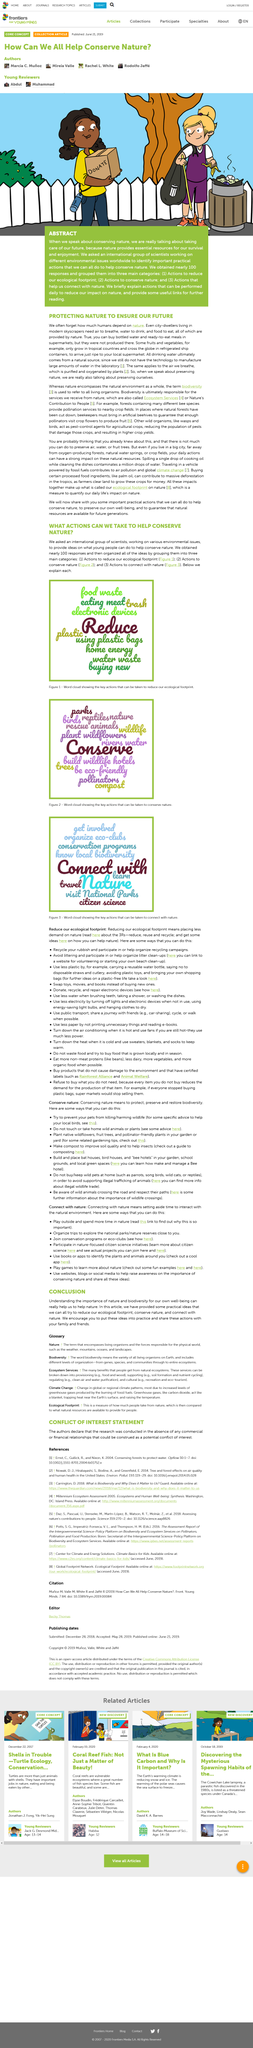Specify some key components in this picture. In nature, we find the essential resources necessary for our survival and enjoyment, which nature graciously provides for us. The article provided various ideas for reducing ecological footprint, conserving nature, and connecting with nature, including practical and easily implementable suggestions that everyone can try. We received approximately 100 responses from scientists working on different environmental issues worldwide when we asked for important practical actions to conserve nature. The international group of scientists who are working on various environmental issues were asked by "they" to provide ideas on what young people can do to help conserve nature. The authors organized the responses they received into three main categories: the first category included responses that were primarily concerned with the cost of owning an electric vehicle, the second category included responses that were primarily concerned with the environmental impact of owning an electric vehicle, and the third category included responses that were primarily concerned with the convenience of charging an electric vehicle. 